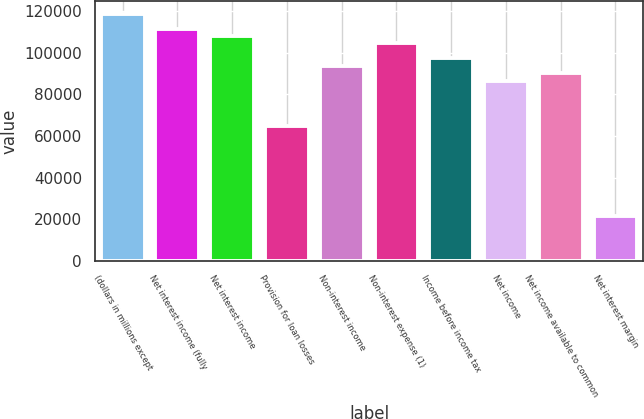Convert chart. <chart><loc_0><loc_0><loc_500><loc_500><bar_chart><fcel>(dollars in millions except<fcel>Net interest income (fully<fcel>Net interest income<fcel>Provision for loan losses<fcel>Non-interest income<fcel>Non-interest expense (1)<fcel>Income before income tax<fcel>Net income<fcel>Net income available to common<fcel>Net interest margin<nl><fcel>118872<fcel>111668<fcel>108066<fcel>64839.5<fcel>93657.1<fcel>104464<fcel>97259.2<fcel>86452.7<fcel>90054.9<fcel>21613.3<nl></chart> 